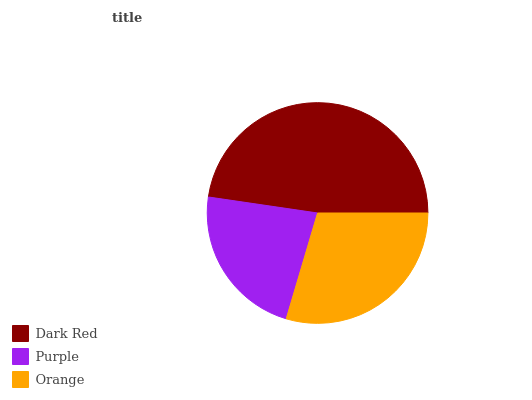Is Purple the minimum?
Answer yes or no. Yes. Is Dark Red the maximum?
Answer yes or no. Yes. Is Orange the minimum?
Answer yes or no. No. Is Orange the maximum?
Answer yes or no. No. Is Orange greater than Purple?
Answer yes or no. Yes. Is Purple less than Orange?
Answer yes or no. Yes. Is Purple greater than Orange?
Answer yes or no. No. Is Orange less than Purple?
Answer yes or no. No. Is Orange the high median?
Answer yes or no. Yes. Is Orange the low median?
Answer yes or no. Yes. Is Dark Red the high median?
Answer yes or no. No. Is Purple the low median?
Answer yes or no. No. 